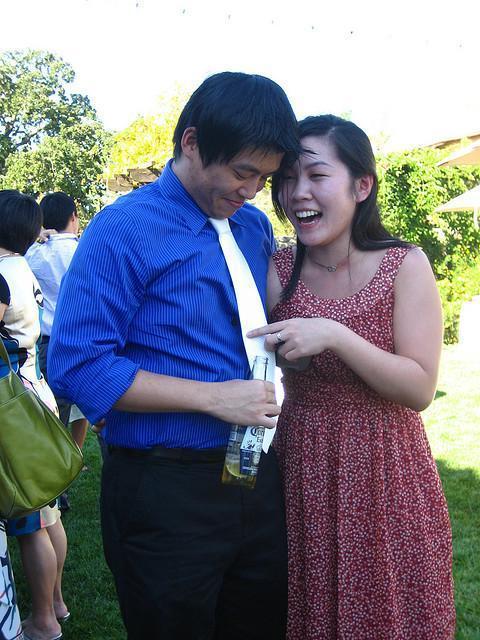How many people are there?
Give a very brief answer. 4. 